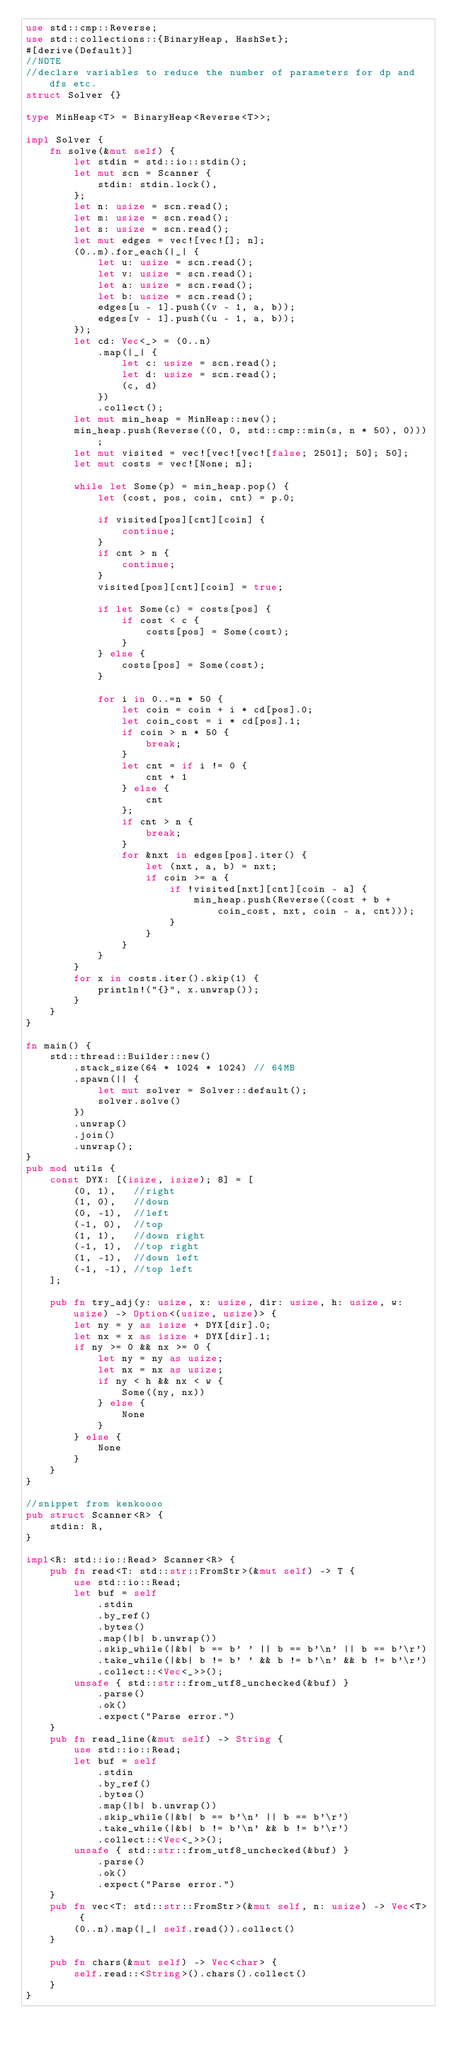Convert code to text. <code><loc_0><loc_0><loc_500><loc_500><_Rust_>use std::cmp::Reverse;
use std::collections::{BinaryHeap, HashSet};
#[derive(Default)]
//NOTE
//declare variables to reduce the number of parameters for dp and dfs etc.
struct Solver {}

type MinHeap<T> = BinaryHeap<Reverse<T>>;

impl Solver {
    fn solve(&mut self) {
        let stdin = std::io::stdin();
        let mut scn = Scanner {
            stdin: stdin.lock(),
        };
        let n: usize = scn.read();
        let m: usize = scn.read();
        let s: usize = scn.read();
        let mut edges = vec![vec![]; n];
        (0..m).for_each(|_| {
            let u: usize = scn.read();
            let v: usize = scn.read();
            let a: usize = scn.read();
            let b: usize = scn.read();
            edges[u - 1].push((v - 1, a, b));
            edges[v - 1].push((u - 1, a, b));
        });
        let cd: Vec<_> = (0..n)
            .map(|_| {
                let c: usize = scn.read();
                let d: usize = scn.read();
                (c, d)
            })
            .collect();
        let mut min_heap = MinHeap::new();
        min_heap.push(Reverse((0, 0, std::cmp::min(s, n * 50), 0)));
        let mut visited = vec![vec![vec![false; 2501]; 50]; 50];
        let mut costs = vec![None; n];

        while let Some(p) = min_heap.pop() {
            let (cost, pos, coin, cnt) = p.0;

            if visited[pos][cnt][coin] {
                continue;
            }
            if cnt > n {
                continue;
            }
            visited[pos][cnt][coin] = true;

            if let Some(c) = costs[pos] {
                if cost < c {
                    costs[pos] = Some(cost);
                }
            } else {
                costs[pos] = Some(cost);
            }

            for i in 0..=n * 50 {
                let coin = coin + i * cd[pos].0;
                let coin_cost = i * cd[pos].1;
                if coin > n * 50 {
                    break;
                }
                let cnt = if i != 0 {
                    cnt + 1
                } else {
                    cnt
                };
                if cnt > n {
                    break;
                }
                for &nxt in edges[pos].iter() {
                    let (nxt, a, b) = nxt;
                    if coin >= a {
                        if !visited[nxt][cnt][coin - a] {
                            min_heap.push(Reverse((cost + b + coin_cost, nxt, coin - a, cnt)));
                        }
                    }
                }
            }
        }
        for x in costs.iter().skip(1) {
            println!("{}", x.unwrap());
        }
    }
}

fn main() {
    std::thread::Builder::new()
        .stack_size(64 * 1024 * 1024) // 64MB
        .spawn(|| {
            let mut solver = Solver::default();
            solver.solve()
        })
        .unwrap()
        .join()
        .unwrap();
}
pub mod utils {
    const DYX: [(isize, isize); 8] = [
        (0, 1),   //right
        (1, 0),   //down
        (0, -1),  //left
        (-1, 0),  //top
        (1, 1),   //down right
        (-1, 1),  //top right
        (1, -1),  //down left
        (-1, -1), //top left
    ];

    pub fn try_adj(y: usize, x: usize, dir: usize, h: usize, w: usize) -> Option<(usize, usize)> {
        let ny = y as isize + DYX[dir].0;
        let nx = x as isize + DYX[dir].1;
        if ny >= 0 && nx >= 0 {
            let ny = ny as usize;
            let nx = nx as usize;
            if ny < h && nx < w {
                Some((ny, nx))
            } else {
                None
            }
        } else {
            None
        }
    }
}

//snippet from kenkoooo
pub struct Scanner<R> {
    stdin: R,
}

impl<R: std::io::Read> Scanner<R> {
    pub fn read<T: std::str::FromStr>(&mut self) -> T {
        use std::io::Read;
        let buf = self
            .stdin
            .by_ref()
            .bytes()
            .map(|b| b.unwrap())
            .skip_while(|&b| b == b' ' || b == b'\n' || b == b'\r')
            .take_while(|&b| b != b' ' && b != b'\n' && b != b'\r')
            .collect::<Vec<_>>();
        unsafe { std::str::from_utf8_unchecked(&buf) }
            .parse()
            .ok()
            .expect("Parse error.")
    }
    pub fn read_line(&mut self) -> String {
        use std::io::Read;
        let buf = self
            .stdin
            .by_ref()
            .bytes()
            .map(|b| b.unwrap())
            .skip_while(|&b| b == b'\n' || b == b'\r')
            .take_while(|&b| b != b'\n' && b != b'\r')
            .collect::<Vec<_>>();
        unsafe { std::str::from_utf8_unchecked(&buf) }
            .parse()
            .ok()
            .expect("Parse error.")
    }
    pub fn vec<T: std::str::FromStr>(&mut self, n: usize) -> Vec<T> {
        (0..n).map(|_| self.read()).collect()
    }

    pub fn chars(&mut self) -> Vec<char> {
        self.read::<String>().chars().collect()
    }
}
</code> 